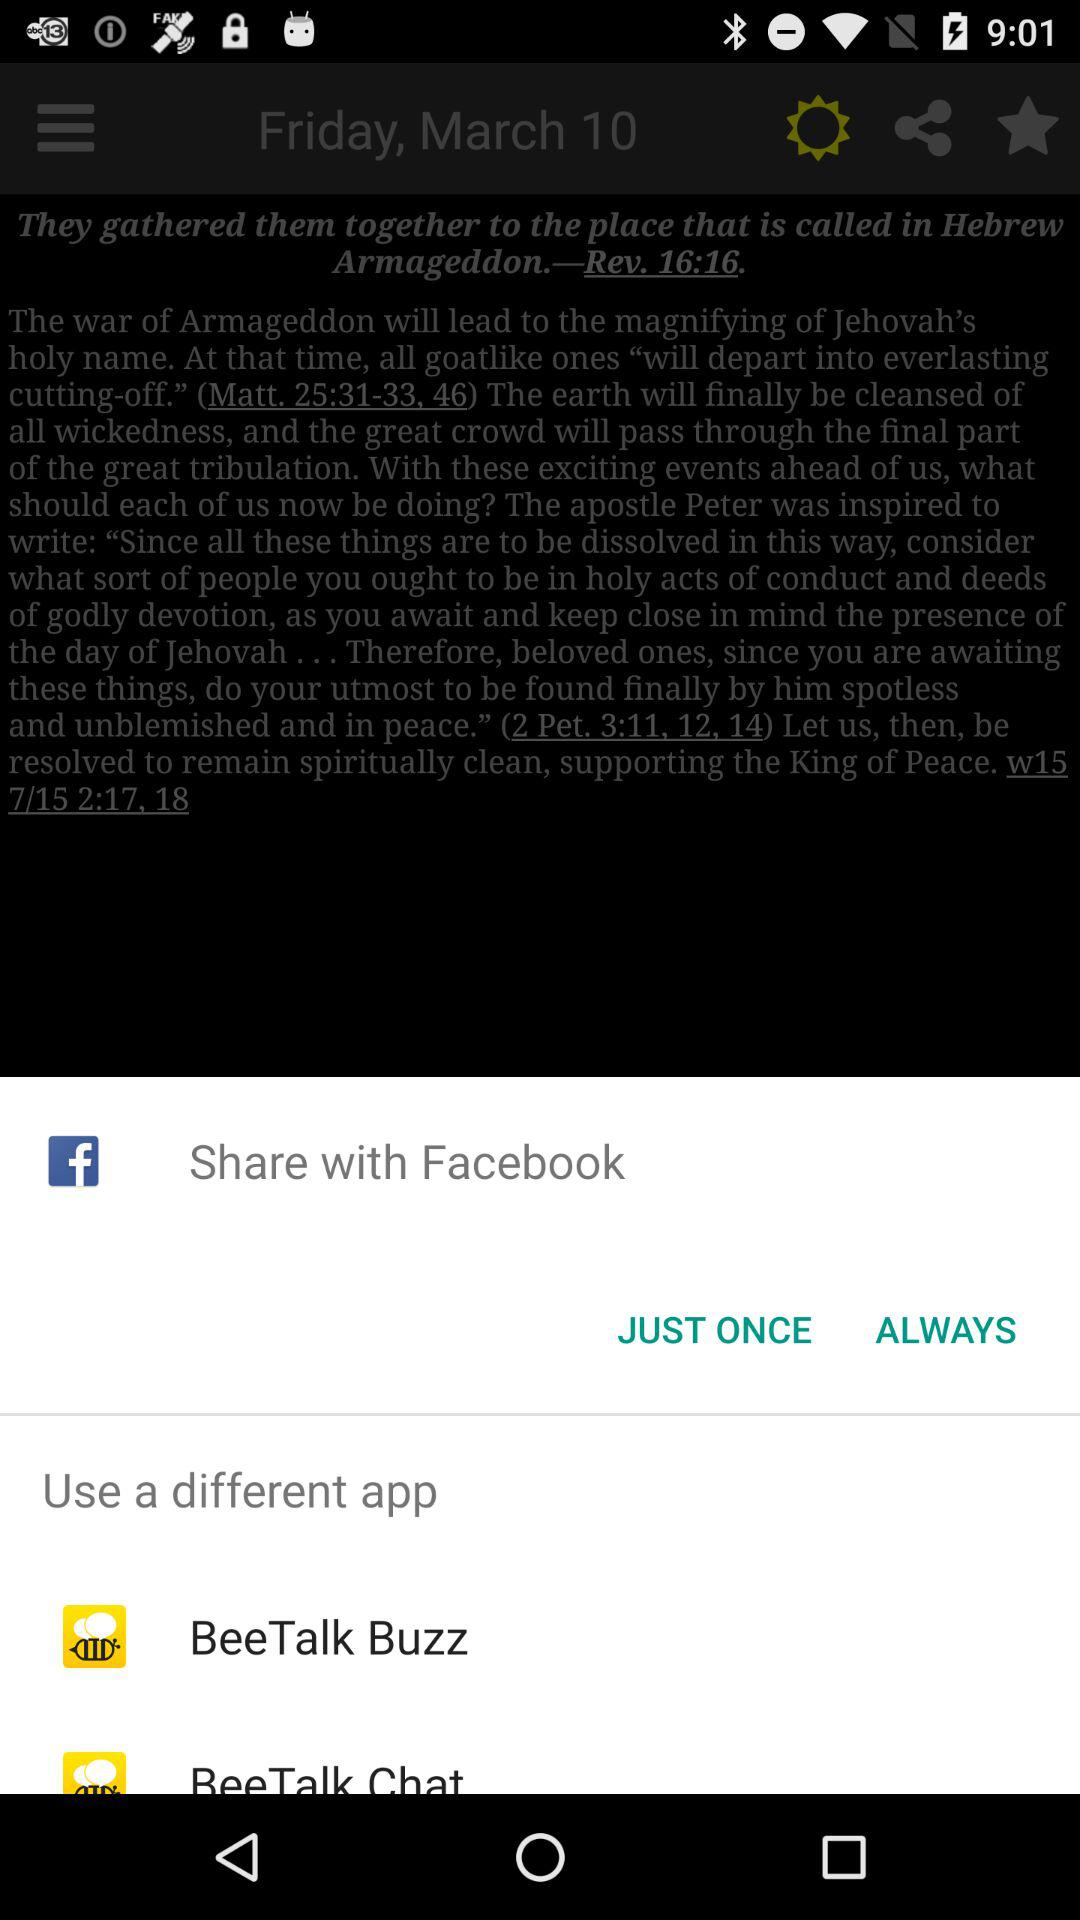What are the different applications given for use? The different given application for use is "BeeTalk Buzz". 